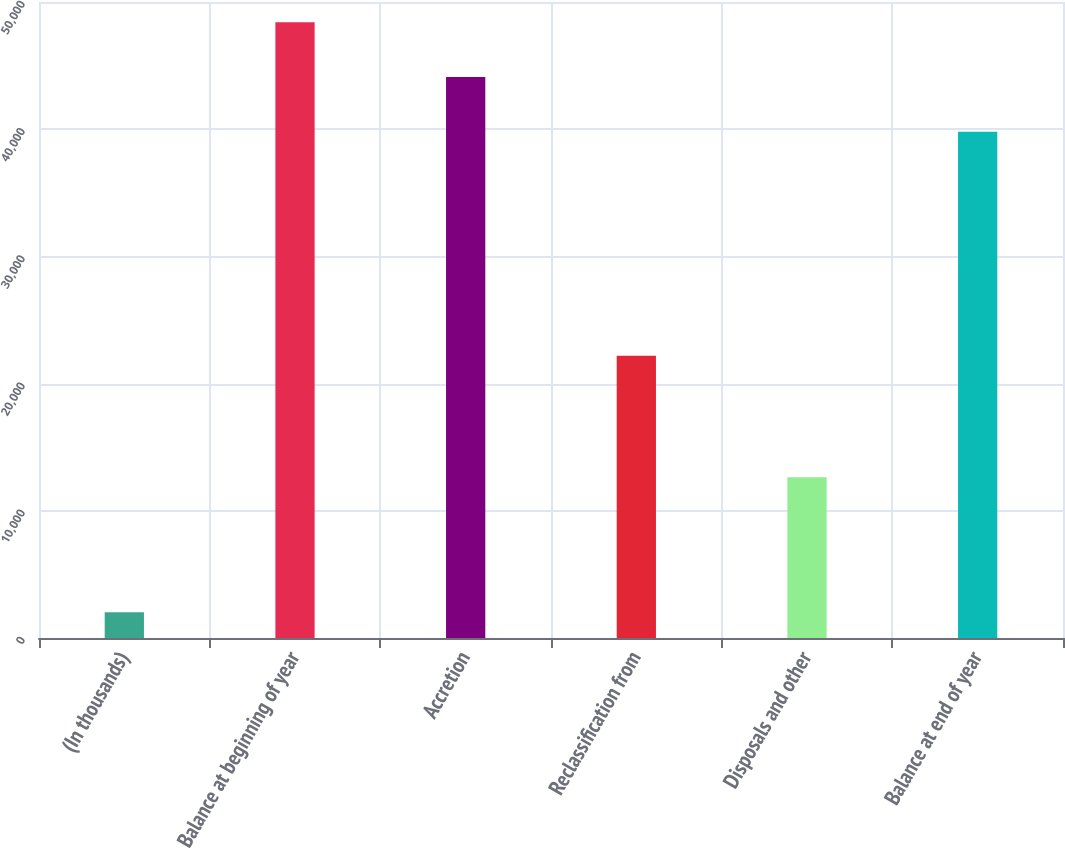Convert chart. <chart><loc_0><loc_0><loc_500><loc_500><bar_chart><fcel>(In thousands)<fcel>Balance at beginning of year<fcel>Accretion<fcel>Reclassification from<fcel>Disposals and other<fcel>Balance at end of year<nl><fcel>2015<fcel>48411<fcel>44107<fcel>22190<fcel>12635<fcel>39803<nl></chart> 